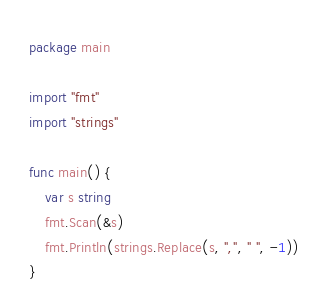<code> <loc_0><loc_0><loc_500><loc_500><_Go_>package main

import "fmt"
import "strings"

func main() {
	var s string
	fmt.Scan(&s)
	fmt.Println(strings.Replace(s, ",", " ", -1))
}</code> 